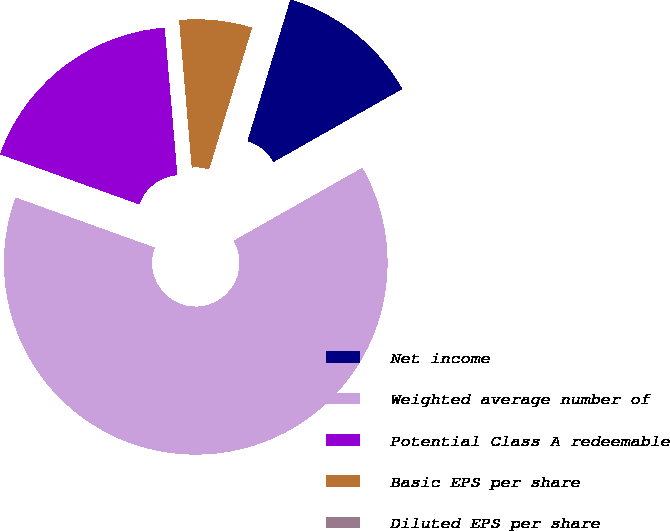Convert chart. <chart><loc_0><loc_0><loc_500><loc_500><pie_chart><fcel>Net income<fcel>Weighted average number of<fcel>Potential Class A redeemable<fcel>Basic EPS per share<fcel>Diluted EPS per share<nl><fcel>12.1%<fcel>63.71%<fcel>18.14%<fcel>6.05%<fcel>0.0%<nl></chart> 